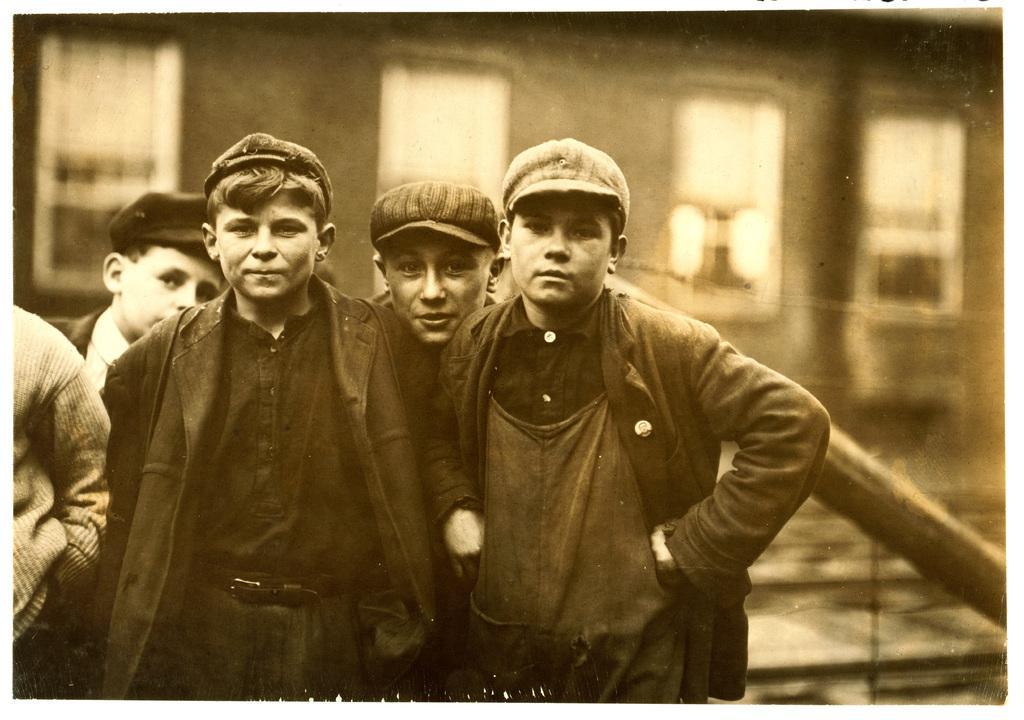How would you summarize this image in a sentence or two? In the front of the image I can see people standing and wearing caps. In the background of the image it is blurry. There is a building and a rod.   